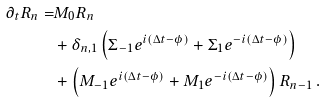Convert formula to latex. <formula><loc_0><loc_0><loc_500><loc_500>\partial _ { t } R _ { n } = & M _ { 0 } R _ { n } \\ & + \delta _ { n , 1 } \left ( \Sigma _ { - 1 } e ^ { i ( \Delta t - \phi ) } + \Sigma _ { 1 } e ^ { - i ( \Delta t - \phi ) } \right ) \\ & + \left ( M _ { - 1 } e ^ { i ( \Delta t - \phi ) } + M _ { 1 } e ^ { - i ( \Delta t - \phi ) } \right ) R _ { n - 1 } \, .</formula> 